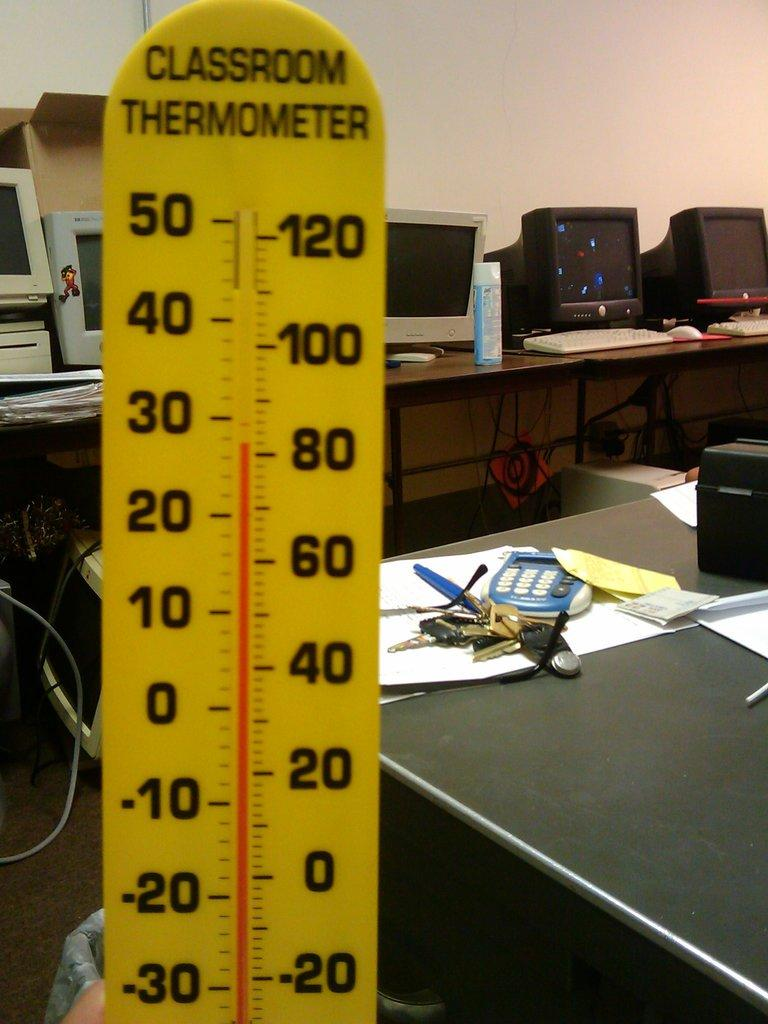Provide a one-sentence caption for the provided image. A CLASSROOM THERMOMETER SHOWS IT IS OVER EIGHTY DEGREES. 